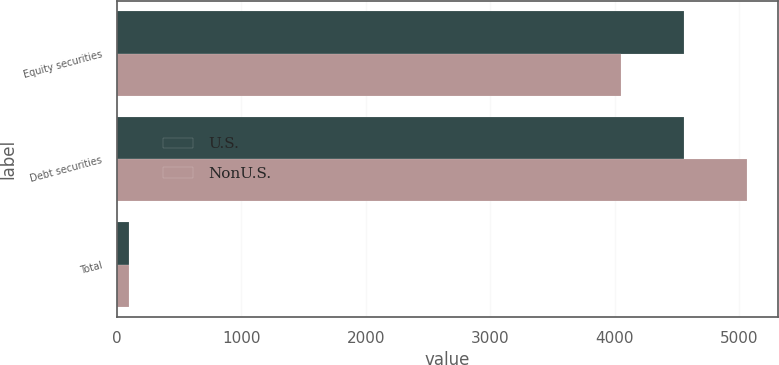Convert chart. <chart><loc_0><loc_0><loc_500><loc_500><stacked_bar_chart><ecel><fcel>Equity securities<fcel>Debt securities<fcel>Total<nl><fcel>U.S.<fcel>4555<fcel>4555<fcel>100<nl><fcel>NonU.S.<fcel>4050<fcel>5060<fcel>100<nl></chart> 